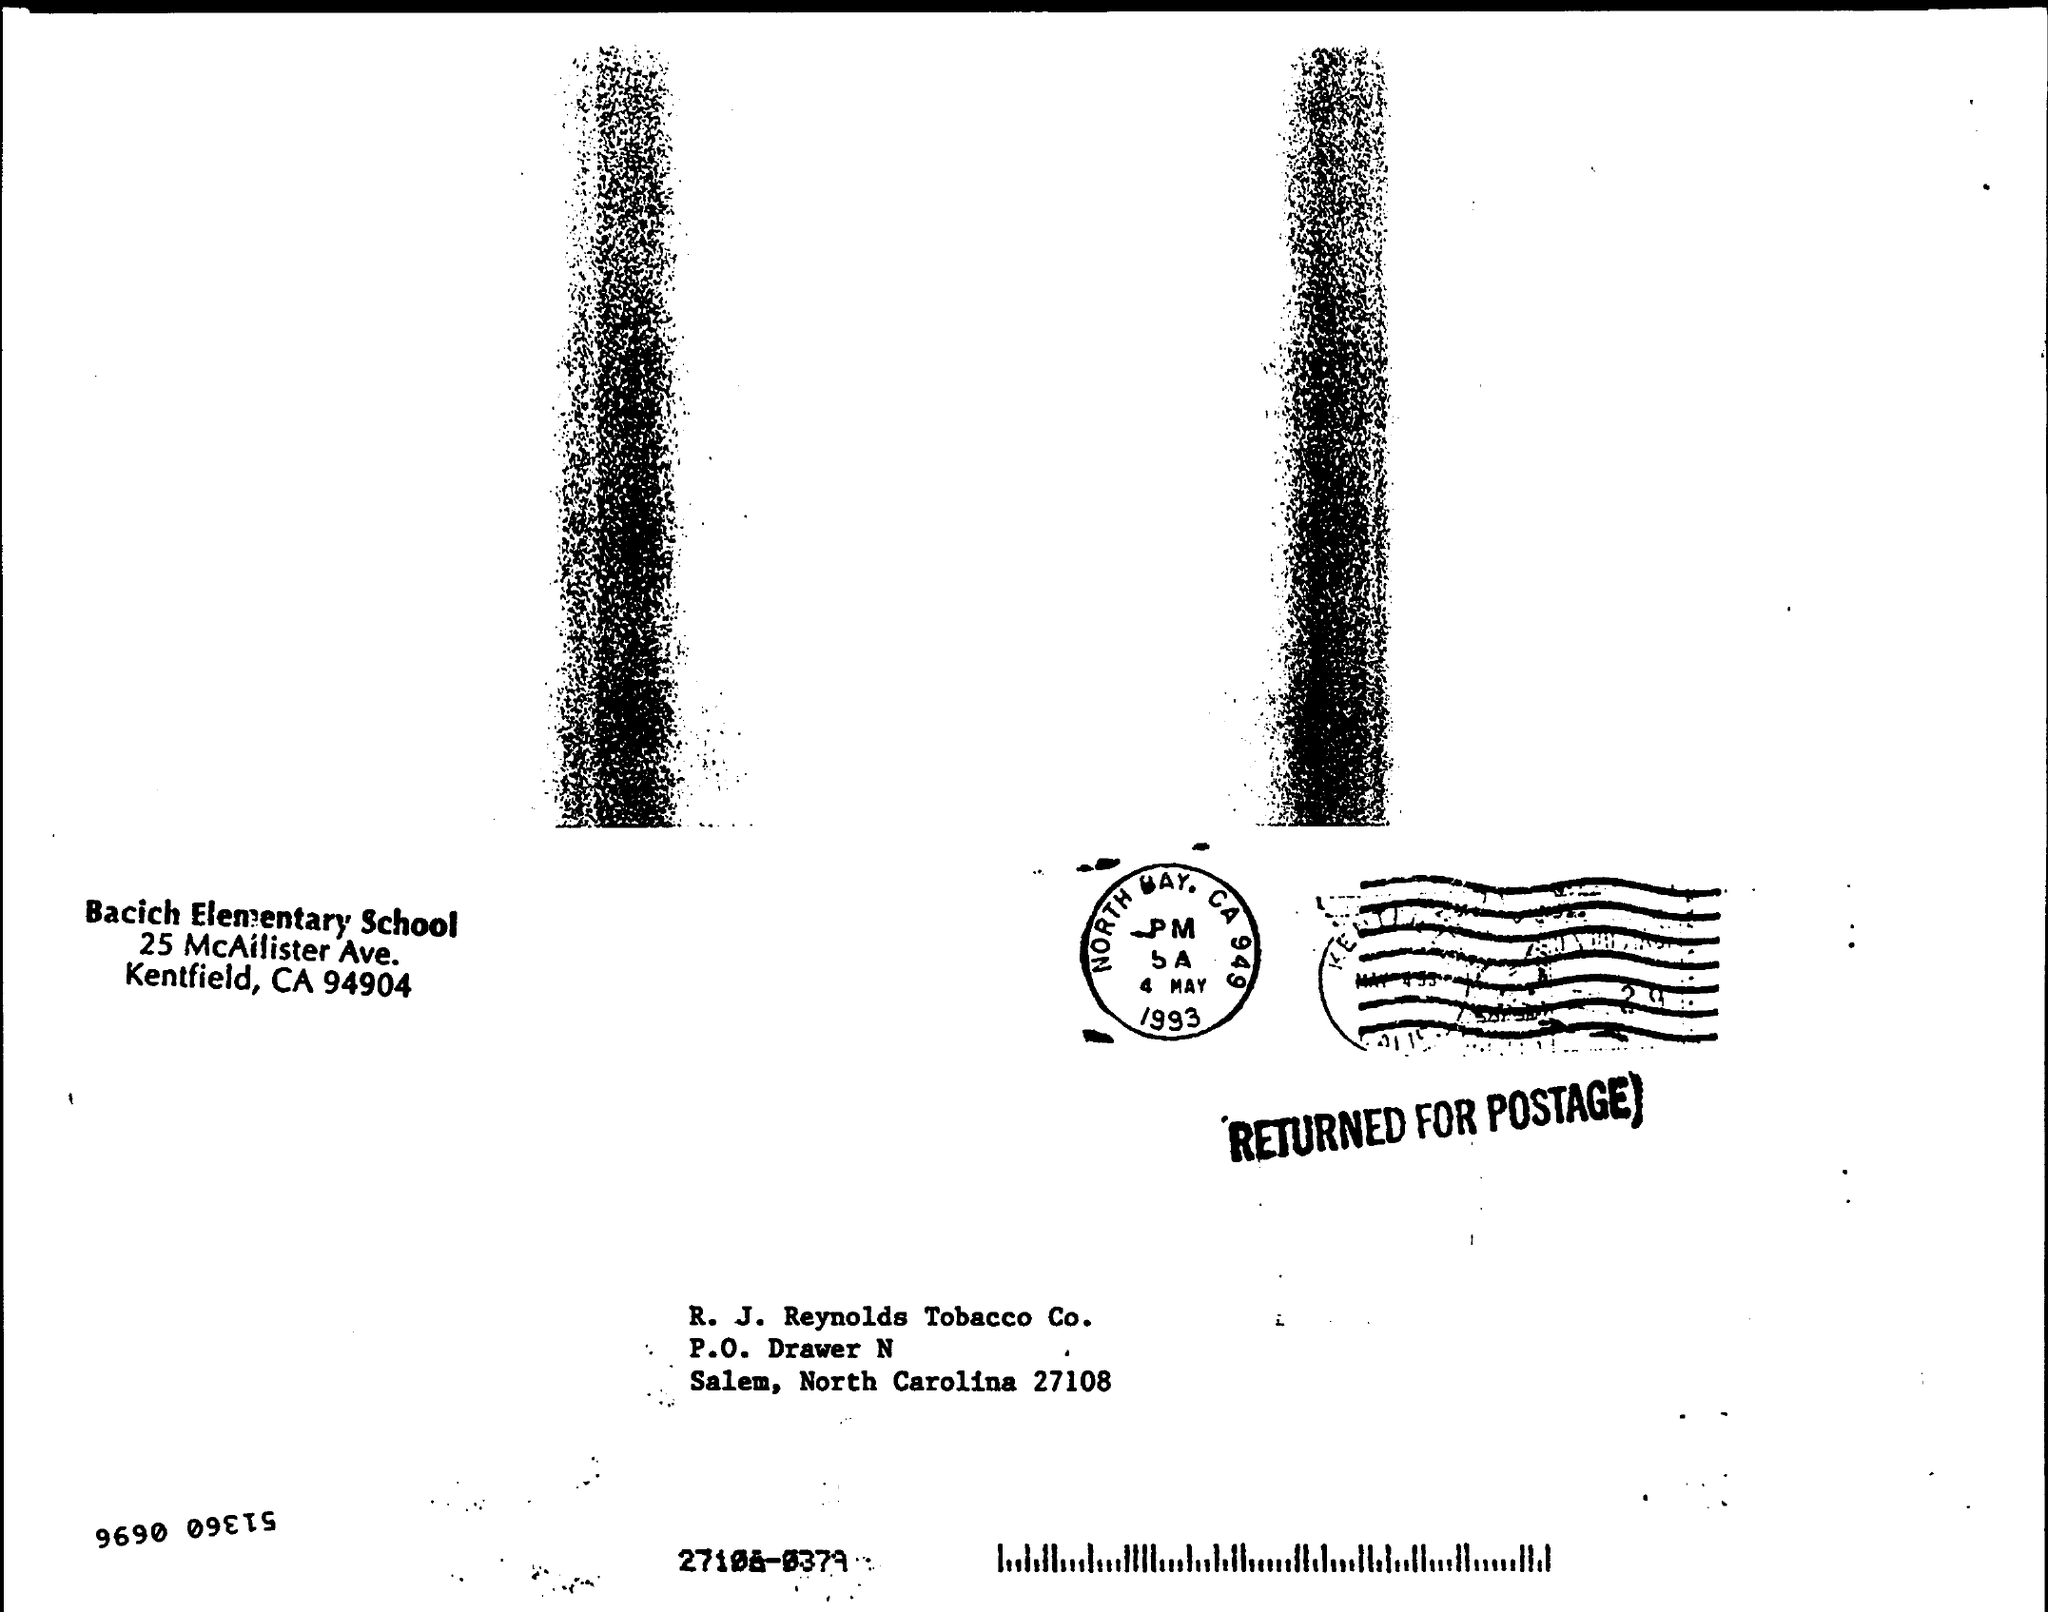What is the date on the stamp?
Make the answer very short. 4 MAY 1993. 